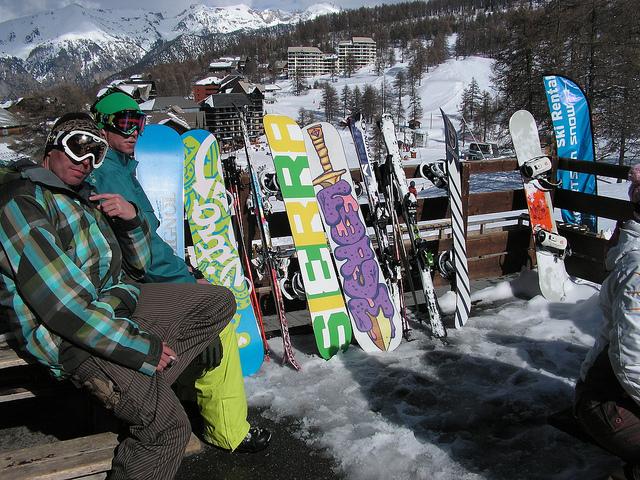Is this a ski park?
Answer briefly. Yes. Where is the building?
Keep it brief. Behind. What do the men wear on their faces?
Answer briefly. Goggles. Are the men color coordinated?
Write a very short answer. Yes. 